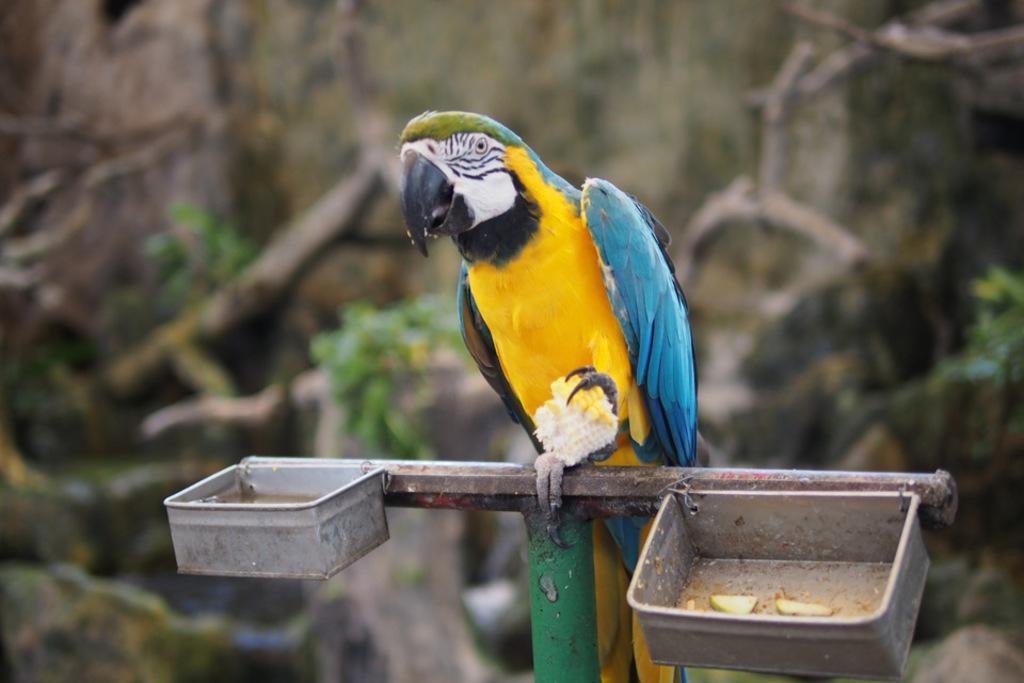Please provide a concise description of this image. In this image, we can see a parrot and there are two small tin boxes, there is a blur background. 